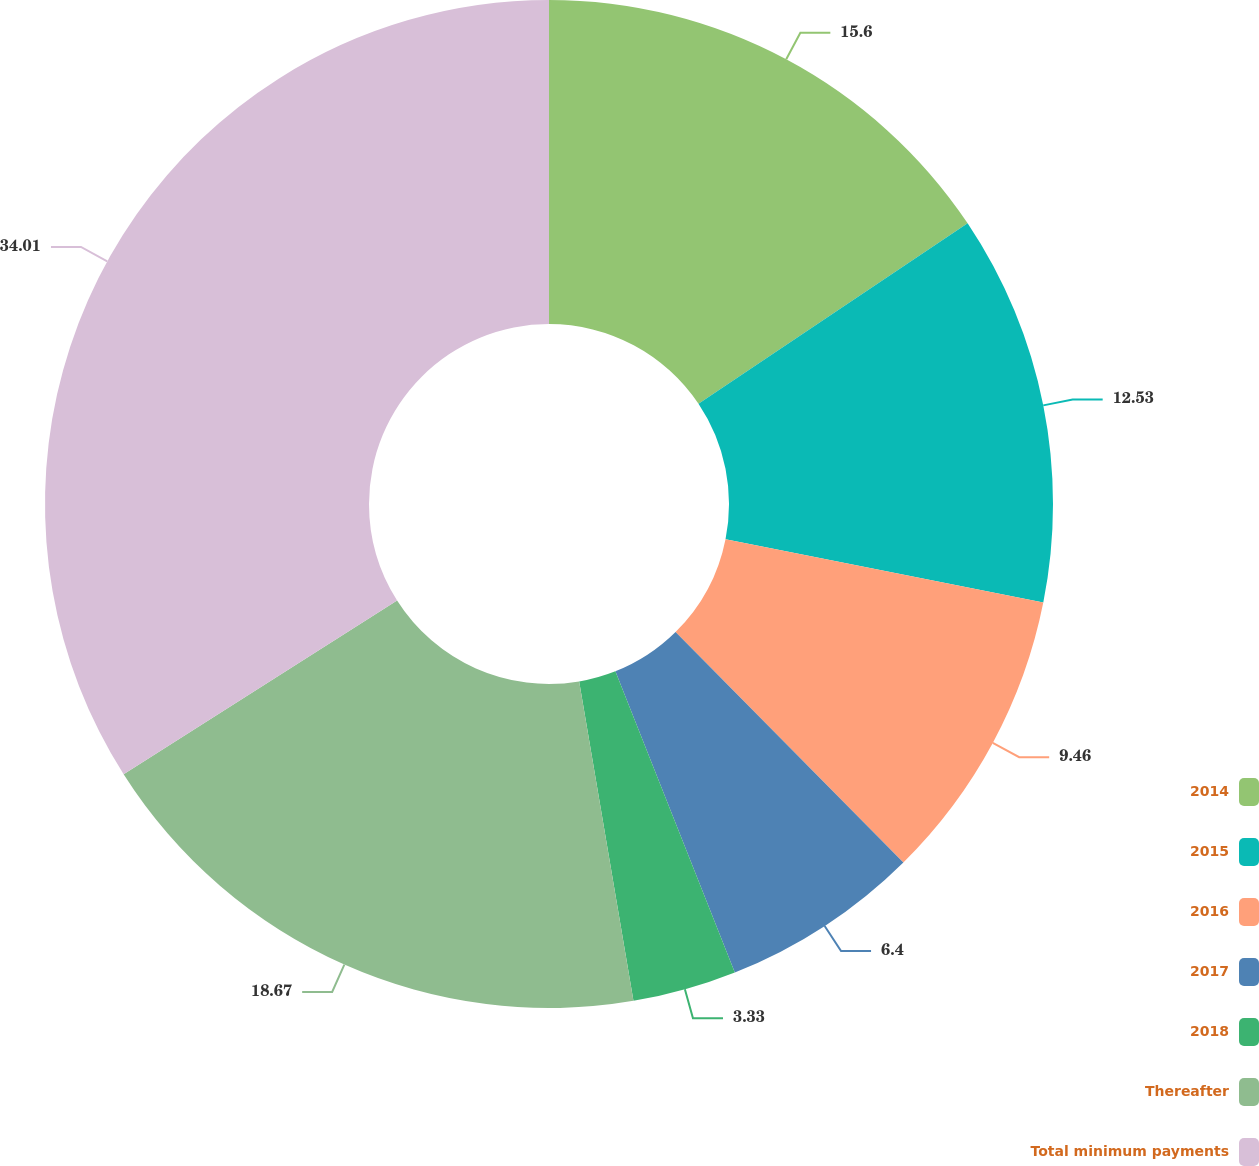Convert chart to OTSL. <chart><loc_0><loc_0><loc_500><loc_500><pie_chart><fcel>2014<fcel>2015<fcel>2016<fcel>2017<fcel>2018<fcel>Thereafter<fcel>Total minimum payments<nl><fcel>15.6%<fcel>12.53%<fcel>9.46%<fcel>6.4%<fcel>3.33%<fcel>18.67%<fcel>34.01%<nl></chart> 